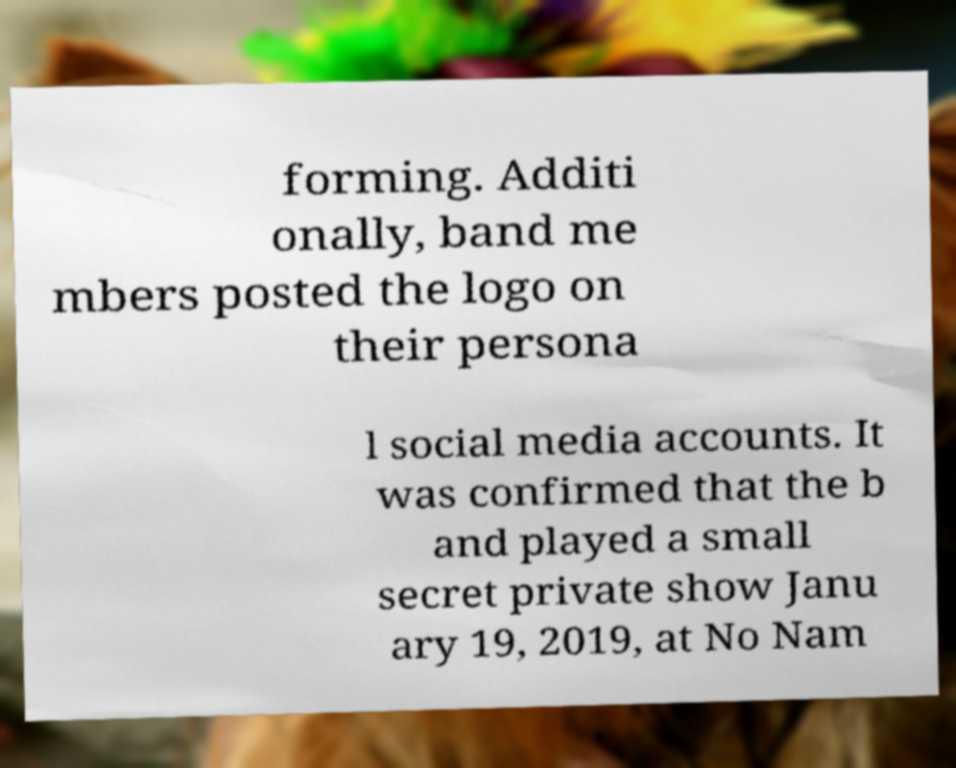Please identify and transcribe the text found in this image. forming. Additi onally, band me mbers posted the logo on their persona l social media accounts. It was confirmed that the b and played a small secret private show Janu ary 19, 2019, at No Nam 